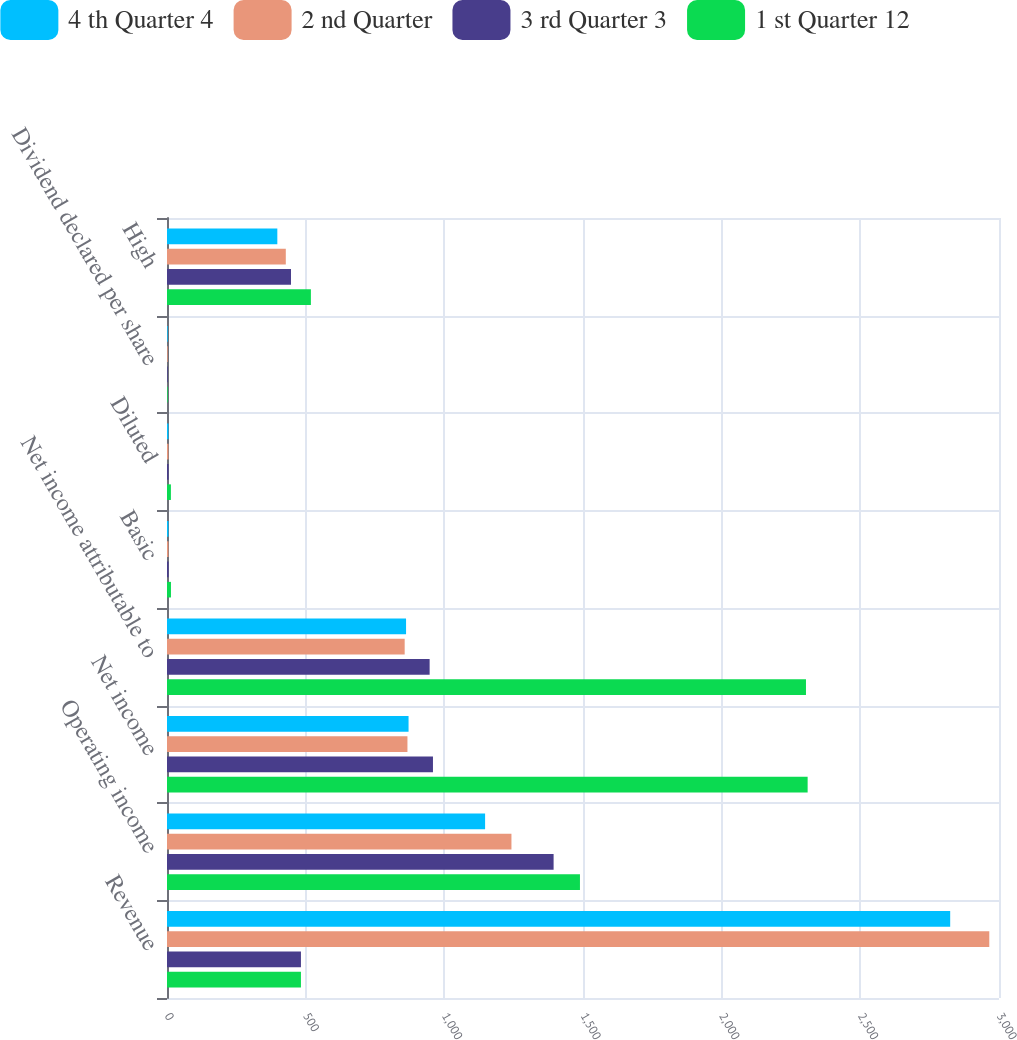<chart> <loc_0><loc_0><loc_500><loc_500><stacked_bar_chart><ecel><fcel>Revenue<fcel>Operating income<fcel>Net income<fcel>Net income attributable to<fcel>Basic<fcel>Diluted<fcel>Dividend declared per share<fcel>High<nl><fcel>4 th Quarter 4<fcel>2824<fcel>1147<fcel>871<fcel>862<fcel>5.29<fcel>5.23<fcel>2.5<fcel>397.81<nl><fcel>2 nd Quarter<fcel>2965<fcel>1242<fcel>867<fcel>857<fcel>5.27<fcel>5.22<fcel>2.5<fcel>428.38<nl><fcel>3 rd Quarter 3<fcel>482.975<fcel>1394<fcel>959<fcel>947<fcel>5.85<fcel>5.78<fcel>2.5<fcel>447.09<nl><fcel>1 st Quarter 12<fcel>482.975<fcel>1489<fcel>2310<fcel>2304<fcel>14.29<fcel>14.07<fcel>2.5<fcel>518.86<nl></chart> 